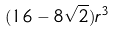Convert formula to latex. <formula><loc_0><loc_0><loc_500><loc_500>( 1 6 - 8 \sqrt { 2 } ) r ^ { 3 }</formula> 